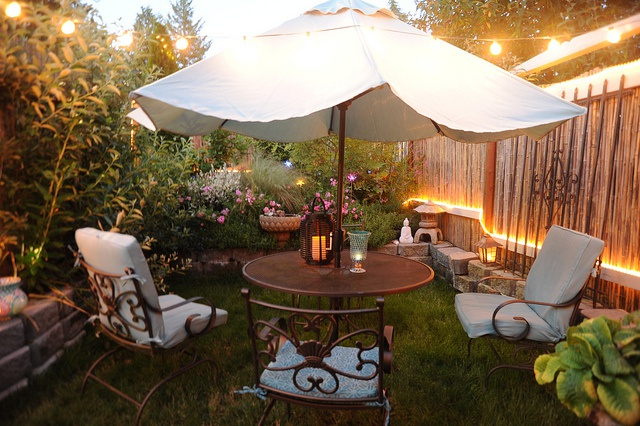Describe the objects in this image and their specific colors. I can see umbrella in gold, white, and gray tones, chair in gold, black, gray, and maroon tones, chair in gold, black, gray, darkgray, and maroon tones, chair in gold, gray, and black tones, and dining table in gold, maroon, black, and gray tones in this image. 